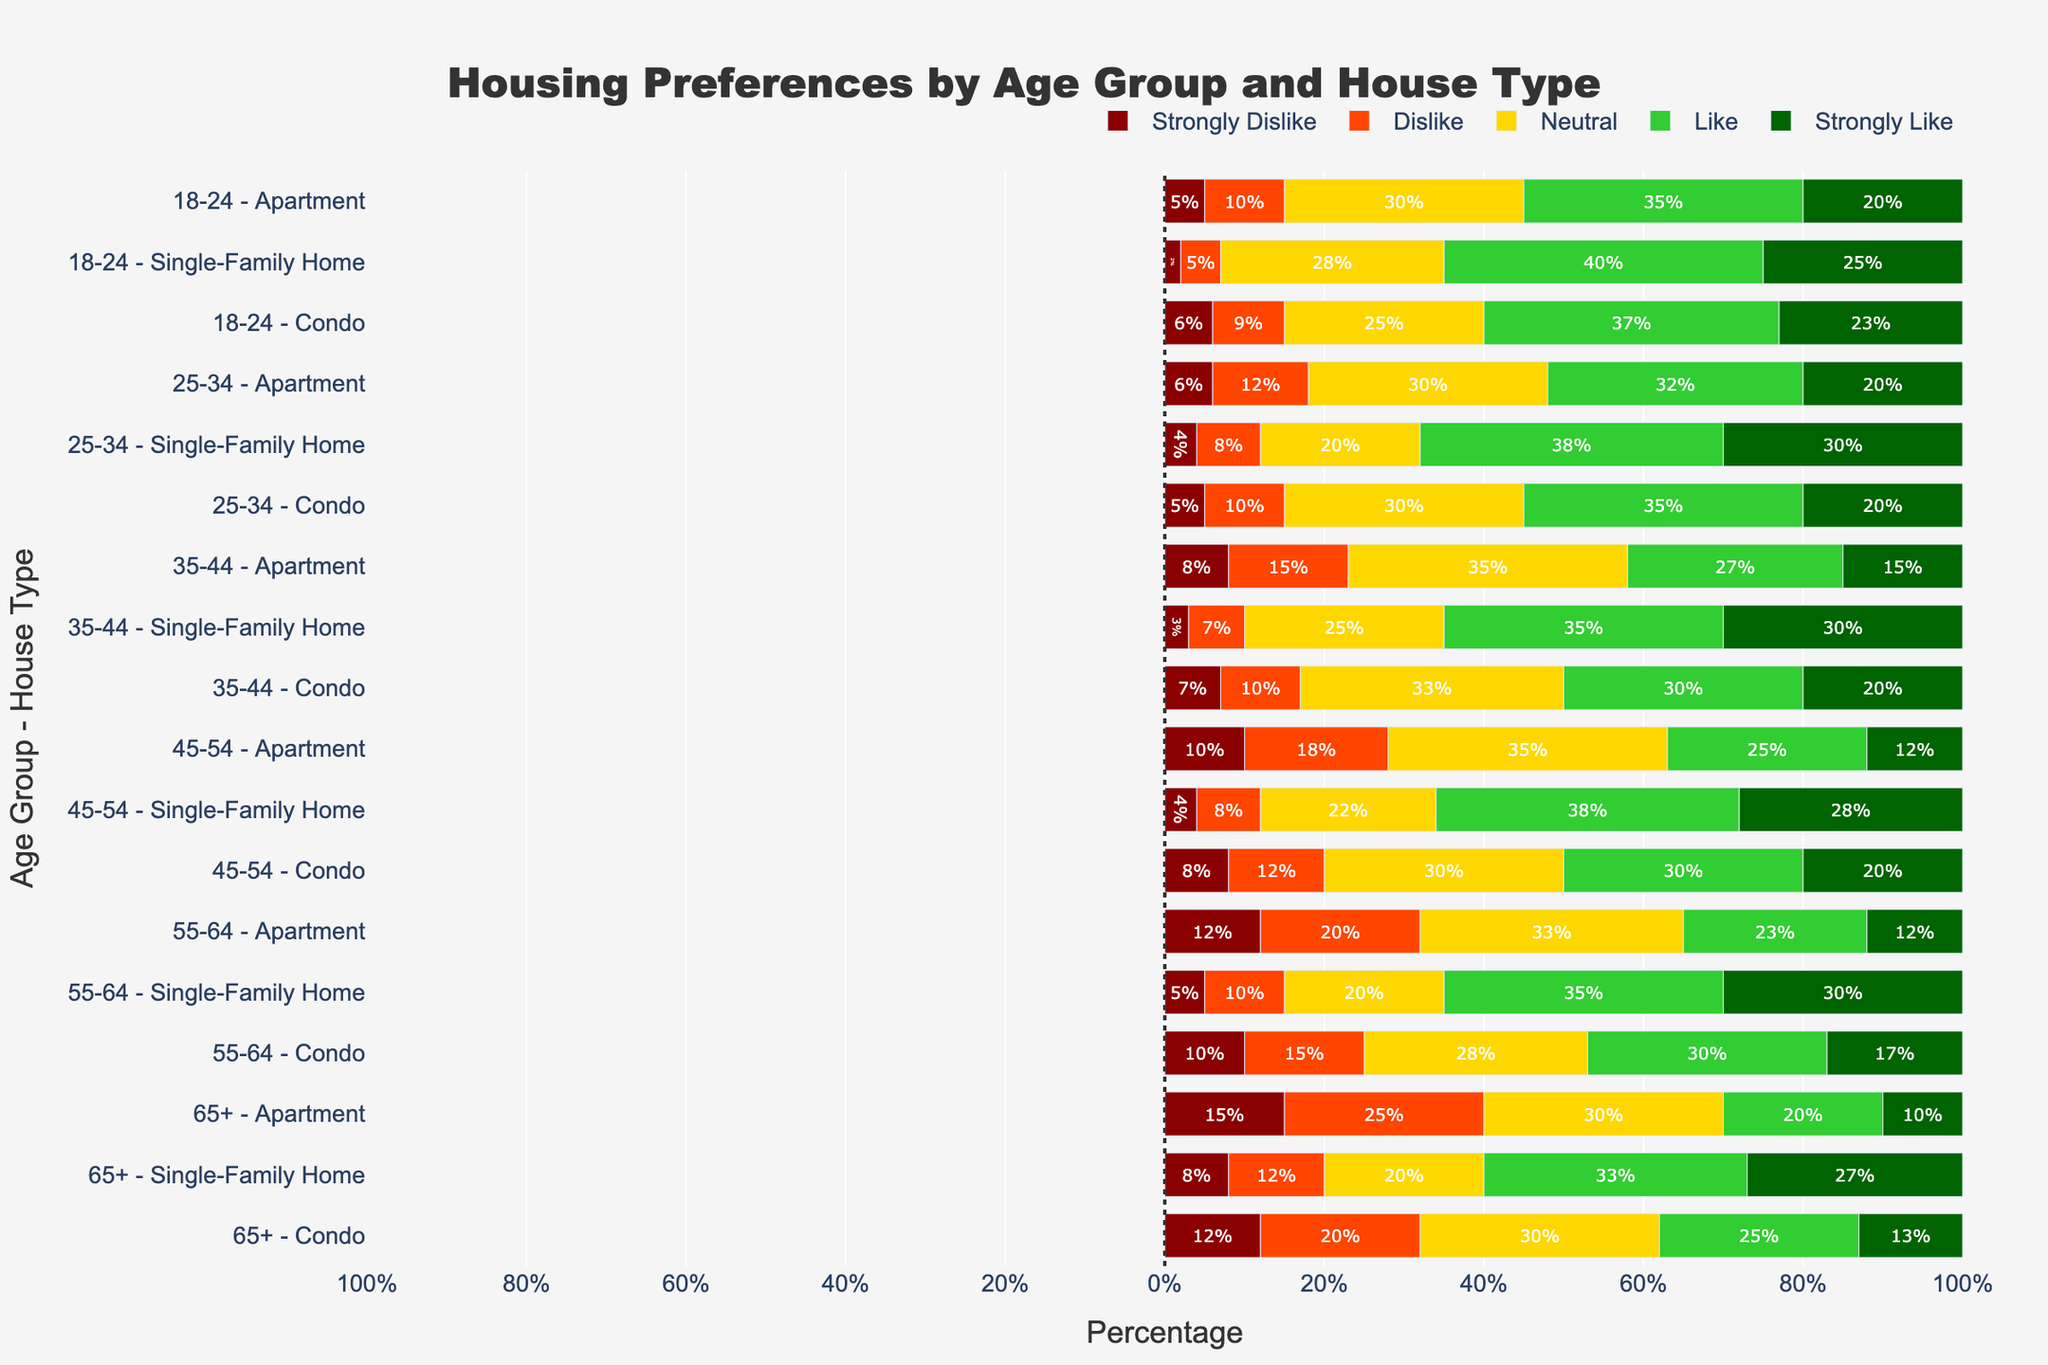What age group has the highest likability for Single-Family Homes? To determine the highest likability, compare the percentages of those who "Like" and "Strongly Like" Single-Family Homes across age groups. The 25-34 age group has the combined highest percentage (38% Like + 30% Strongly Like = 68%).
Answer: 25-34 Which house type is most strongly disliked by the 65+ age group? For the 65+ age group, compare the "Strongly Dislike" percentages for each house type. Apartments have the highest "Strongly Dislike" percentage (15%).
Answer: Apartment What is the overall likability (sum of Like and Strongly Like) for Condos among the 35-44 age group? Sum the percentages of "Like" and "Strongly Like" for Condos in the 35-44 age group (30% Like + 20% Strongly Like = 50%).
Answer: 50% Which age group has the highest neutral opinion on Apartments? Compare the "Neutral" percentages for Apartments across all age groups. The 35-44 age group has the highest with 35%.
Answer: 35-44 What is the difference in strong dislike between the youngest (18-24) and oldest (65+) age groups for Condos? Subtract the "Strongly Dislike" percentage for Condos in the 18-24 age group from the 65+ age group (12% - 6% = 6%).
Answer: 6% How do the overall positive ratings (Like and Strongly Like) for Single-Family Homes vary between the 45-54 and 55-64 age groups? Sum "Like" and "Strongly Like" for both age groups, then compare. For the 45-54 group: 38% + 28% = 66%. For the 55-64 group: 35% + 30% = 65%. The 45-54 age group is slightly higher by 1%.
Answer: 1% more for 45-54 Which demographic (age group and house type) shows the highest strong dislike percentage? Identify the highest "Strongly Dislike" percentage from all age groups and house types. The 65+ age group shows the highest strong dislike for Apartments (15%).
Answer: 65+ Apartments What is the overall negative sentiment (sum of Strongly Dislike and Dislike) for Condos in the 25-34 age group? Add the percentages of "Strongly Dislike" and "Dislike" for Condos in the 25-34 age group (5% + 10% = 15%).
Answer: 15% Which house type is most liked by the 18-24 age group, and what is the percentage? Compare the "Like" percentages for each house type in the 18-24 age group. Single-Family Homes have the highest with 40%.
Answer: Single-Family Home, 40% What is the total percentage of people aged 45-54 who have a negative or neutral opinion on Apartments? Add "Strongly Dislike," "Dislike," and "Neutral" percentages for Apartments in the 45-54 age group (10% + 18% + 35% = 63%).
Answer: 63% 